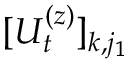Convert formula to latex. <formula><loc_0><loc_0><loc_500><loc_500>[ U _ { t } ^ { ( z ) } ] _ { k , j _ { 1 } }</formula> 